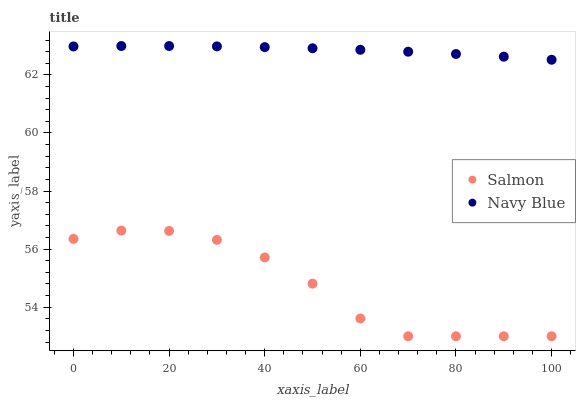Does Salmon have the minimum area under the curve?
Answer yes or no. Yes. Does Navy Blue have the maximum area under the curve?
Answer yes or no. Yes. Does Salmon have the maximum area under the curve?
Answer yes or no. No. Is Navy Blue the smoothest?
Answer yes or no. Yes. Is Salmon the roughest?
Answer yes or no. Yes. Is Salmon the smoothest?
Answer yes or no. No. Does Salmon have the lowest value?
Answer yes or no. Yes. Does Navy Blue have the highest value?
Answer yes or no. Yes. Does Salmon have the highest value?
Answer yes or no. No. Is Salmon less than Navy Blue?
Answer yes or no. Yes. Is Navy Blue greater than Salmon?
Answer yes or no. Yes. Does Salmon intersect Navy Blue?
Answer yes or no. No. 